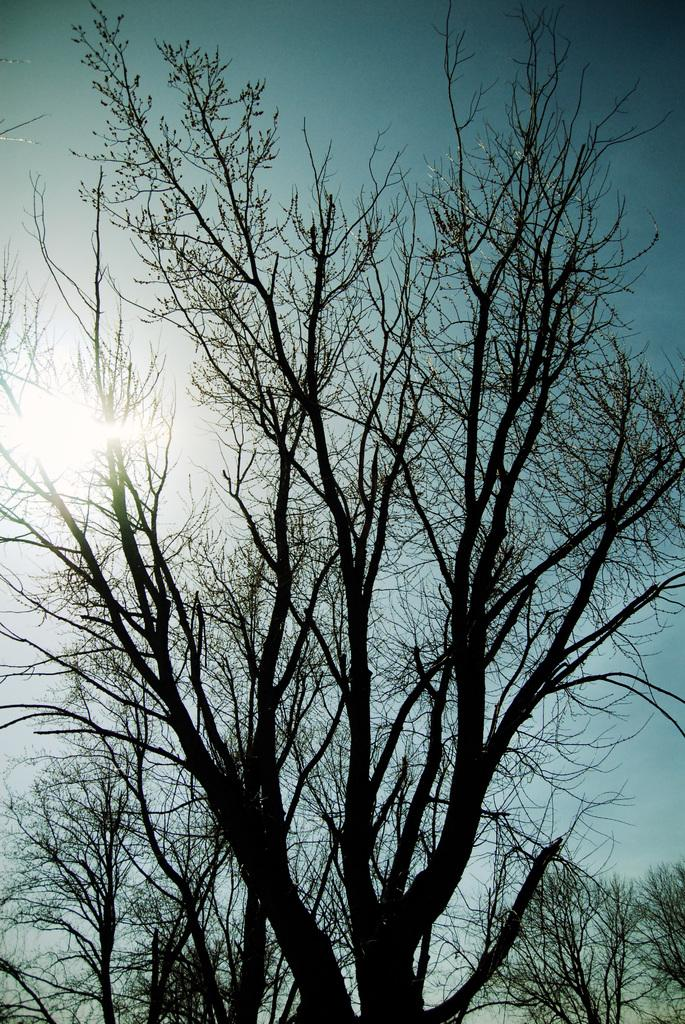What type of plant is visible in the image? There is a tree with branches in the image. What is the condition of the tree's leaves? The tree has no leaves. What can be seen in the background of the image? There are trees in the background of the image. What is visible in the sky in the image? The sky is visible in the image, and sunlight is present. What type of umbrella is being used by the tree in the image? There is no umbrella present in the image; it is a tree with branches and no leaves. In what year was the tree in the image planted? The provided facts do not include information about the year the tree was planted, so it cannot be determined from the image. 